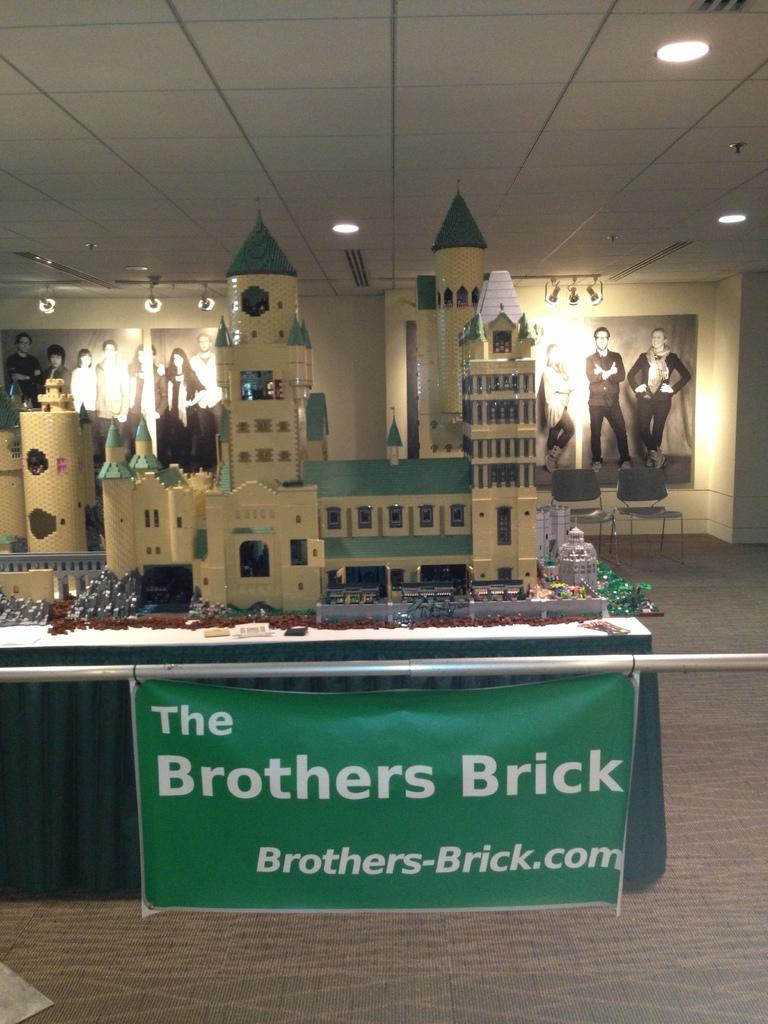<image>
Give a short and clear explanation of the subsequent image. A model castle made out of legos with a sign reading "The Brothers Brick" in front of it. 